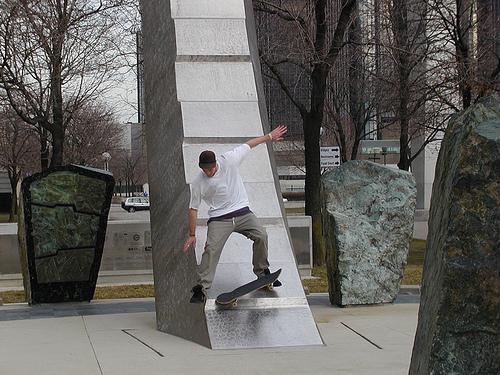Why is the person standing on the snowboard?
Concise answer only. No. What color is the man's t-shirt?
Answer briefly. White. Is this man falling?
Write a very short answer. Yes. Is it spring time?
Keep it brief. No. 